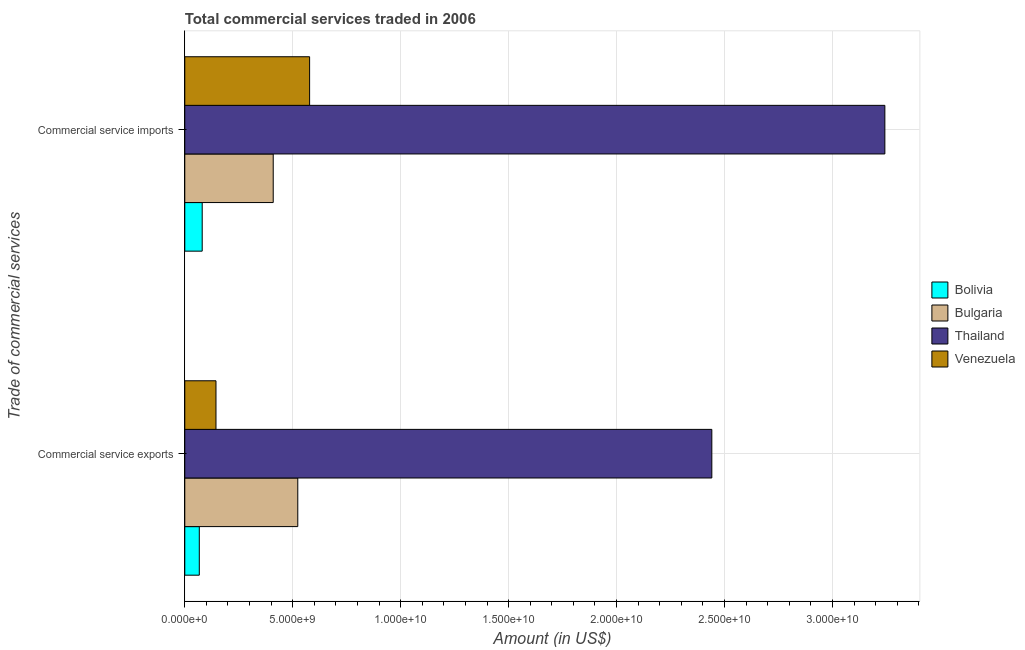Are the number of bars per tick equal to the number of legend labels?
Keep it short and to the point. Yes. How many bars are there on the 1st tick from the top?
Your response must be concise. 4. How many bars are there on the 2nd tick from the bottom?
Provide a succinct answer. 4. What is the label of the 2nd group of bars from the top?
Keep it short and to the point. Commercial service exports. What is the amount of commercial service exports in Bolivia?
Make the answer very short. 6.73e+08. Across all countries, what is the maximum amount of commercial service imports?
Ensure brevity in your answer.  3.24e+1. Across all countries, what is the minimum amount of commercial service exports?
Keep it short and to the point. 6.73e+08. In which country was the amount of commercial service imports maximum?
Your answer should be compact. Thailand. In which country was the amount of commercial service imports minimum?
Make the answer very short. Bolivia. What is the total amount of commercial service exports in the graph?
Provide a short and direct response. 3.18e+1. What is the difference between the amount of commercial service imports in Bulgaria and that in Thailand?
Provide a short and direct response. -2.83e+1. What is the difference between the amount of commercial service imports in Bulgaria and the amount of commercial service exports in Venezuela?
Give a very brief answer. 2.65e+09. What is the average amount of commercial service exports per country?
Provide a short and direct response. 7.94e+09. What is the difference between the amount of commercial service exports and amount of commercial service imports in Bulgaria?
Provide a succinct answer. 1.14e+09. In how many countries, is the amount of commercial service exports greater than 29000000000 US$?
Your answer should be very brief. 0. What is the ratio of the amount of commercial service imports in Thailand to that in Bulgaria?
Your answer should be compact. 7.92. Is the amount of commercial service exports in Bolivia less than that in Thailand?
Offer a very short reply. Yes. What does the 4th bar from the top in Commercial service imports represents?
Your answer should be compact. Bolivia. What does the 3rd bar from the bottom in Commercial service exports represents?
Your answer should be very brief. Thailand. Are all the bars in the graph horizontal?
Your answer should be compact. Yes. Are the values on the major ticks of X-axis written in scientific E-notation?
Ensure brevity in your answer.  Yes. Does the graph contain grids?
Ensure brevity in your answer.  Yes. Where does the legend appear in the graph?
Your answer should be very brief. Center right. What is the title of the graph?
Keep it short and to the point. Total commercial services traded in 2006. Does "France" appear as one of the legend labels in the graph?
Make the answer very short. No. What is the label or title of the Y-axis?
Your response must be concise. Trade of commercial services. What is the Amount (in US$) in Bolivia in Commercial service exports?
Your answer should be very brief. 6.73e+08. What is the Amount (in US$) in Bulgaria in Commercial service exports?
Provide a succinct answer. 5.23e+09. What is the Amount (in US$) of Thailand in Commercial service exports?
Give a very brief answer. 2.44e+1. What is the Amount (in US$) of Venezuela in Commercial service exports?
Provide a succinct answer. 1.44e+09. What is the Amount (in US$) in Bolivia in Commercial service imports?
Give a very brief answer. 8.07e+08. What is the Amount (in US$) in Bulgaria in Commercial service imports?
Provide a short and direct response. 4.10e+09. What is the Amount (in US$) of Thailand in Commercial service imports?
Your answer should be very brief. 3.24e+1. What is the Amount (in US$) of Venezuela in Commercial service imports?
Ensure brevity in your answer.  5.78e+09. Across all Trade of commercial services, what is the maximum Amount (in US$) of Bolivia?
Ensure brevity in your answer.  8.07e+08. Across all Trade of commercial services, what is the maximum Amount (in US$) of Bulgaria?
Offer a terse response. 5.23e+09. Across all Trade of commercial services, what is the maximum Amount (in US$) of Thailand?
Offer a terse response. 3.24e+1. Across all Trade of commercial services, what is the maximum Amount (in US$) in Venezuela?
Provide a short and direct response. 5.78e+09. Across all Trade of commercial services, what is the minimum Amount (in US$) in Bolivia?
Ensure brevity in your answer.  6.73e+08. Across all Trade of commercial services, what is the minimum Amount (in US$) in Bulgaria?
Your response must be concise. 4.10e+09. Across all Trade of commercial services, what is the minimum Amount (in US$) of Thailand?
Offer a very short reply. 2.44e+1. Across all Trade of commercial services, what is the minimum Amount (in US$) in Venezuela?
Your answer should be compact. 1.44e+09. What is the total Amount (in US$) of Bolivia in the graph?
Ensure brevity in your answer.  1.48e+09. What is the total Amount (in US$) in Bulgaria in the graph?
Offer a terse response. 9.33e+09. What is the total Amount (in US$) in Thailand in the graph?
Give a very brief answer. 5.68e+1. What is the total Amount (in US$) in Venezuela in the graph?
Provide a succinct answer. 7.23e+09. What is the difference between the Amount (in US$) in Bolivia in Commercial service exports and that in Commercial service imports?
Your response must be concise. -1.34e+08. What is the difference between the Amount (in US$) in Bulgaria in Commercial service exports and that in Commercial service imports?
Your response must be concise. 1.14e+09. What is the difference between the Amount (in US$) in Thailand in Commercial service exports and that in Commercial service imports?
Ensure brevity in your answer.  -8.02e+09. What is the difference between the Amount (in US$) of Venezuela in Commercial service exports and that in Commercial service imports?
Provide a short and direct response. -4.34e+09. What is the difference between the Amount (in US$) of Bolivia in Commercial service exports and the Amount (in US$) of Bulgaria in Commercial service imports?
Ensure brevity in your answer.  -3.42e+09. What is the difference between the Amount (in US$) in Bolivia in Commercial service exports and the Amount (in US$) in Thailand in Commercial service imports?
Your response must be concise. -3.18e+1. What is the difference between the Amount (in US$) in Bolivia in Commercial service exports and the Amount (in US$) in Venezuela in Commercial service imports?
Make the answer very short. -5.11e+09. What is the difference between the Amount (in US$) of Bulgaria in Commercial service exports and the Amount (in US$) of Thailand in Commercial service imports?
Ensure brevity in your answer.  -2.72e+1. What is the difference between the Amount (in US$) in Bulgaria in Commercial service exports and the Amount (in US$) in Venezuela in Commercial service imports?
Your response must be concise. -5.48e+08. What is the difference between the Amount (in US$) of Thailand in Commercial service exports and the Amount (in US$) of Venezuela in Commercial service imports?
Ensure brevity in your answer.  1.86e+1. What is the average Amount (in US$) in Bolivia per Trade of commercial services?
Ensure brevity in your answer.  7.40e+08. What is the average Amount (in US$) of Bulgaria per Trade of commercial services?
Your answer should be very brief. 4.67e+09. What is the average Amount (in US$) in Thailand per Trade of commercial services?
Make the answer very short. 2.84e+1. What is the average Amount (in US$) of Venezuela per Trade of commercial services?
Make the answer very short. 3.61e+09. What is the difference between the Amount (in US$) of Bolivia and Amount (in US$) of Bulgaria in Commercial service exports?
Provide a short and direct response. -4.56e+09. What is the difference between the Amount (in US$) in Bolivia and Amount (in US$) in Thailand in Commercial service exports?
Ensure brevity in your answer.  -2.37e+1. What is the difference between the Amount (in US$) of Bolivia and Amount (in US$) of Venezuela in Commercial service exports?
Your response must be concise. -7.72e+08. What is the difference between the Amount (in US$) in Bulgaria and Amount (in US$) in Thailand in Commercial service exports?
Make the answer very short. -1.92e+1. What is the difference between the Amount (in US$) in Bulgaria and Amount (in US$) in Venezuela in Commercial service exports?
Offer a very short reply. 3.79e+09. What is the difference between the Amount (in US$) in Thailand and Amount (in US$) in Venezuela in Commercial service exports?
Your answer should be compact. 2.30e+1. What is the difference between the Amount (in US$) in Bolivia and Amount (in US$) in Bulgaria in Commercial service imports?
Ensure brevity in your answer.  -3.29e+09. What is the difference between the Amount (in US$) in Bolivia and Amount (in US$) in Thailand in Commercial service imports?
Your response must be concise. -3.16e+1. What is the difference between the Amount (in US$) in Bolivia and Amount (in US$) in Venezuela in Commercial service imports?
Give a very brief answer. -4.98e+09. What is the difference between the Amount (in US$) of Bulgaria and Amount (in US$) of Thailand in Commercial service imports?
Your answer should be compact. -2.83e+1. What is the difference between the Amount (in US$) in Bulgaria and Amount (in US$) in Venezuela in Commercial service imports?
Your answer should be compact. -1.69e+09. What is the difference between the Amount (in US$) in Thailand and Amount (in US$) in Venezuela in Commercial service imports?
Make the answer very short. 2.66e+1. What is the ratio of the Amount (in US$) in Bolivia in Commercial service exports to that in Commercial service imports?
Make the answer very short. 0.83. What is the ratio of the Amount (in US$) in Bulgaria in Commercial service exports to that in Commercial service imports?
Make the answer very short. 1.28. What is the ratio of the Amount (in US$) in Thailand in Commercial service exports to that in Commercial service imports?
Make the answer very short. 0.75. What is the ratio of the Amount (in US$) in Venezuela in Commercial service exports to that in Commercial service imports?
Keep it short and to the point. 0.25. What is the difference between the highest and the second highest Amount (in US$) in Bolivia?
Your answer should be very brief. 1.34e+08. What is the difference between the highest and the second highest Amount (in US$) in Bulgaria?
Give a very brief answer. 1.14e+09. What is the difference between the highest and the second highest Amount (in US$) of Thailand?
Make the answer very short. 8.02e+09. What is the difference between the highest and the second highest Amount (in US$) of Venezuela?
Make the answer very short. 4.34e+09. What is the difference between the highest and the lowest Amount (in US$) of Bolivia?
Ensure brevity in your answer.  1.34e+08. What is the difference between the highest and the lowest Amount (in US$) in Bulgaria?
Keep it short and to the point. 1.14e+09. What is the difference between the highest and the lowest Amount (in US$) in Thailand?
Provide a succinct answer. 8.02e+09. What is the difference between the highest and the lowest Amount (in US$) in Venezuela?
Offer a terse response. 4.34e+09. 